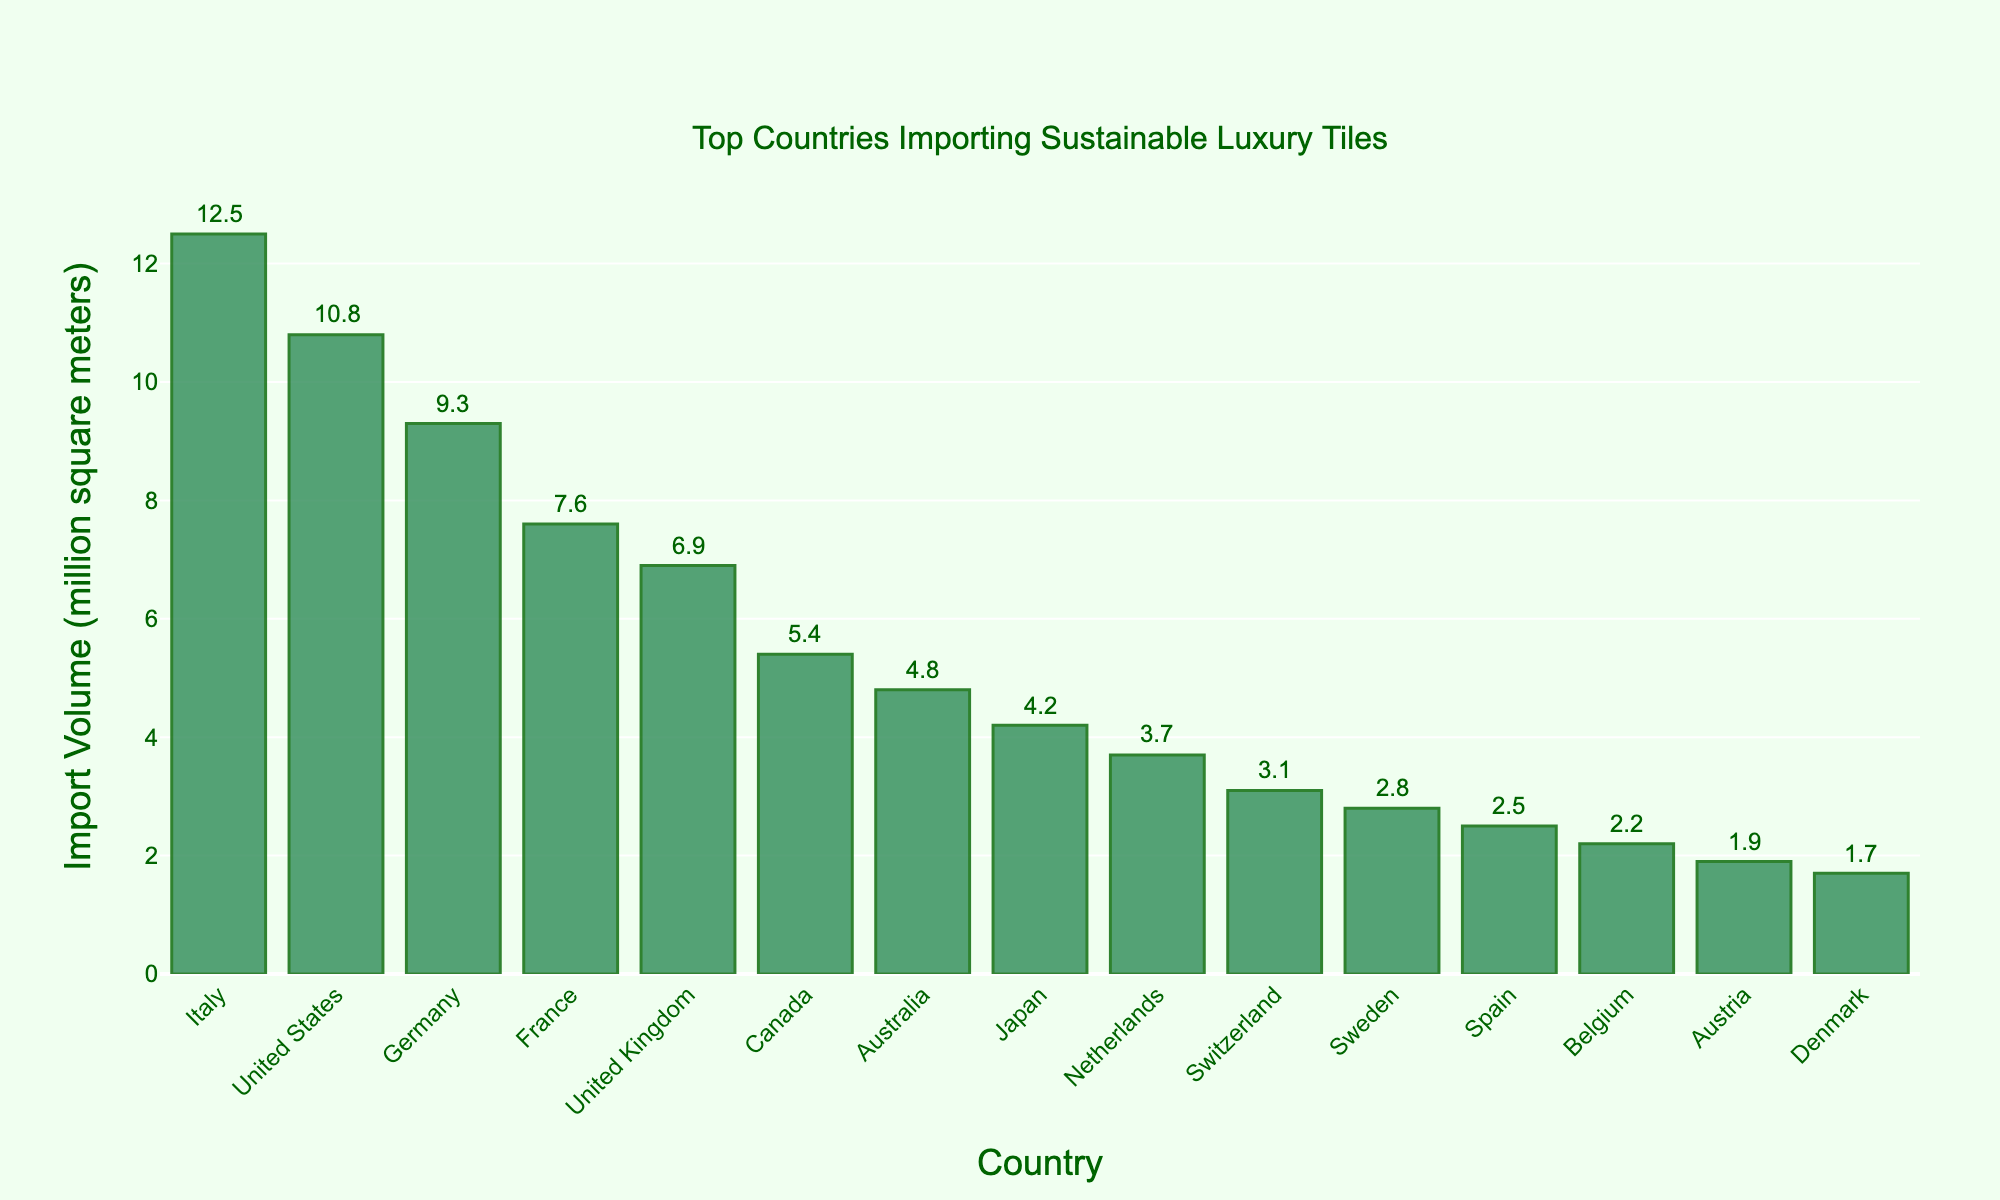Which country imports the most sustainable luxury tiles by volume? The country that imports the most sustainable luxury tiles will have the highest bar in the chart. Italy has the highest bar.
Answer: Italy Which country imports more sustainable luxury tiles, Germany or France? Compare the height of the bars for Germany and France. Germany's bar is taller than France's.
Answer: Germany What is the combined import volume of Canada and Australia? Add the import volumes of Canada (5.4 million square meters) and Australia (4.8 million square meters). 5.4 + 4.8 = 10.2
Answer: 10.2 How much more tile does the United States import compared to Sweden? Subtract Sweden's import volume (2.8 million square meters) from the United States' (10.8 million square meters). 10.8 - 2.8 = 8
Answer: 8 Which countries import less than 3 million square meters of sustainable luxury tiles? Check the bars with import volumes less than 3 million square meters. The countries are Belgium, Austria, and Denmark.
Answer: Belgium, Austria, Denmark What is the average import volume of the top 5 importing countries? Sum the import volumes of the top 5 countries (Italy, United States, Germany, France, United Kingdom) and divide by 5. (12.5 + 10.8 + 9.3 + 7.6 + 6.9) / 5 = 47.1 / 5 = 9.42
Answer: 9.42 Which country has the smallest import volume, and what is it? Identify the country with the shortest bar. Denmark has the shortest bar with an import volume of 1.7 million square meters.
Answer: Denmark, 1.7 How many countries import between 5 and 10 million square meters of tiles? Count the countries with bars between 5 and 10 million square meters. There are 4 such countries: United Kingdom, Canada, Australia, and France.
Answer: 4 What is the difference in import volume between the country with the highest and the country with the lowest imports? Subtract the import volume of Denmark (1.7 million square meters) from Italy (12.5 million square meters). 12.5 - 1.7 = 10.8
Answer: 10.8 